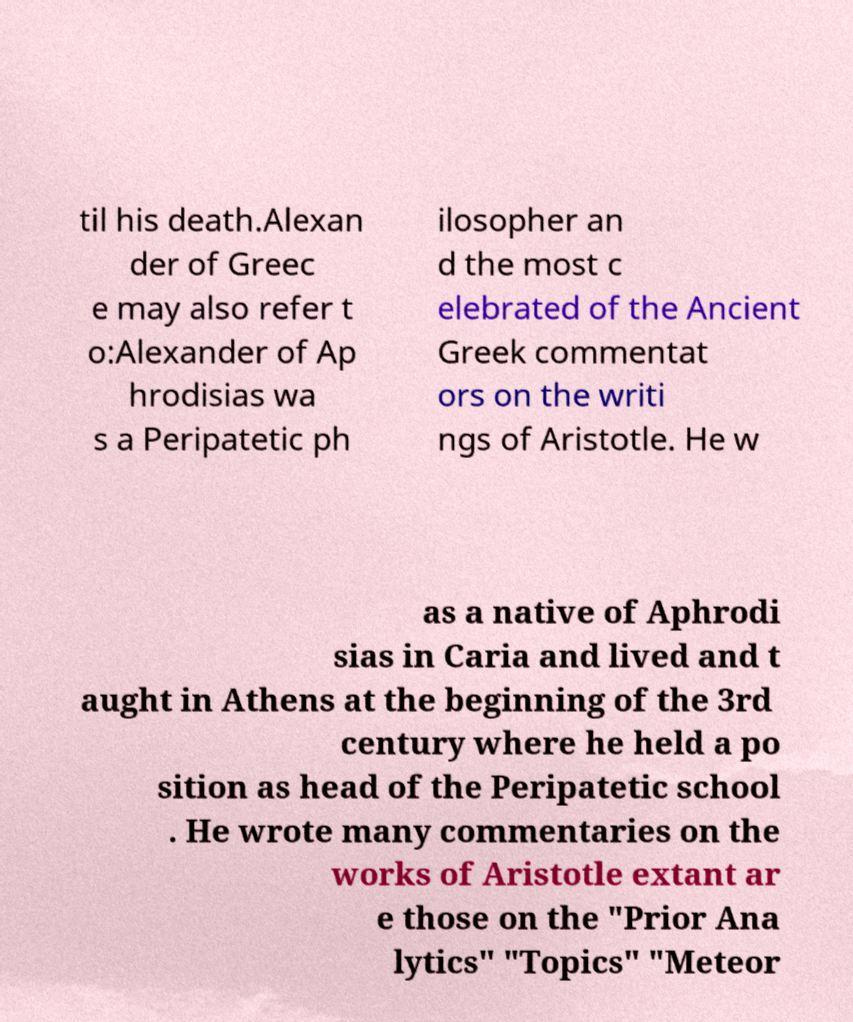Could you assist in decoding the text presented in this image and type it out clearly? til his death.Alexan der of Greec e may also refer t o:Alexander of Ap hrodisias wa s a Peripatetic ph ilosopher an d the most c elebrated of the Ancient Greek commentat ors on the writi ngs of Aristotle. He w as a native of Aphrodi sias in Caria and lived and t aught in Athens at the beginning of the 3rd century where he held a po sition as head of the Peripatetic school . He wrote many commentaries on the works of Aristotle extant ar e those on the "Prior Ana lytics" "Topics" "Meteor 